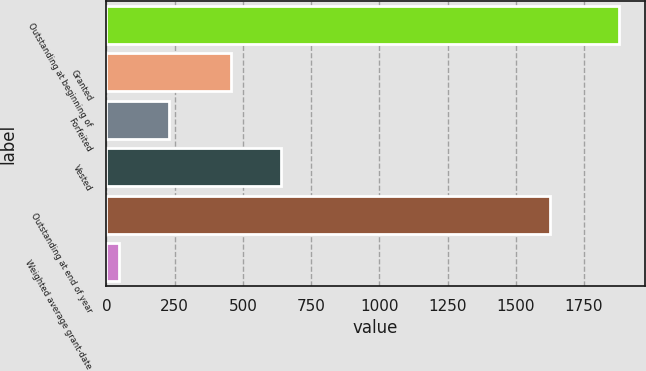Convert chart to OTSL. <chart><loc_0><loc_0><loc_500><loc_500><bar_chart><fcel>Outstanding at beginning of<fcel>Granted<fcel>Forfeited<fcel>Vested<fcel>Outstanding at end of year<fcel>Weighted average grant-date<nl><fcel>1878<fcel>456<fcel>228.89<fcel>639.23<fcel>1627<fcel>45.66<nl></chart> 